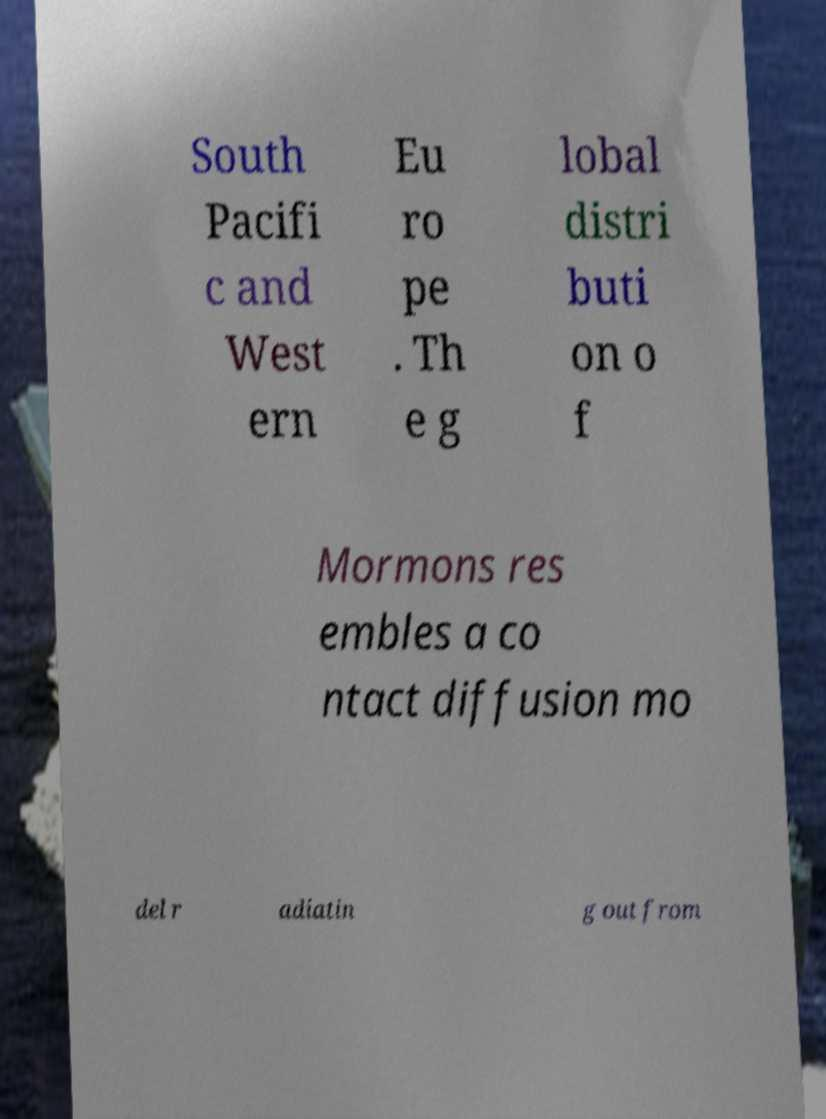Could you extract and type out the text from this image? South Pacifi c and West ern Eu ro pe . Th e g lobal distri buti on o f Mormons res embles a co ntact diffusion mo del r adiatin g out from 